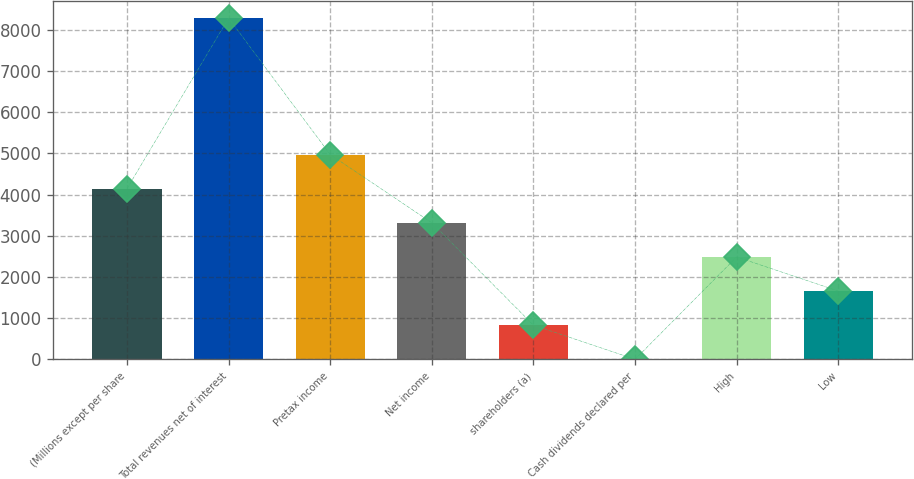<chart> <loc_0><loc_0><loc_500><loc_500><bar_chart><fcel>(Millions except per share<fcel>Total revenues net of interest<fcel>Pretax income<fcel>Net income<fcel>shareholders (a)<fcel>Cash dividends declared per<fcel>High<fcel>Low<nl><fcel>4142.14<fcel>8284<fcel>4970.51<fcel>3313.77<fcel>828.66<fcel>0.29<fcel>2485.4<fcel>1657.03<nl></chart> 